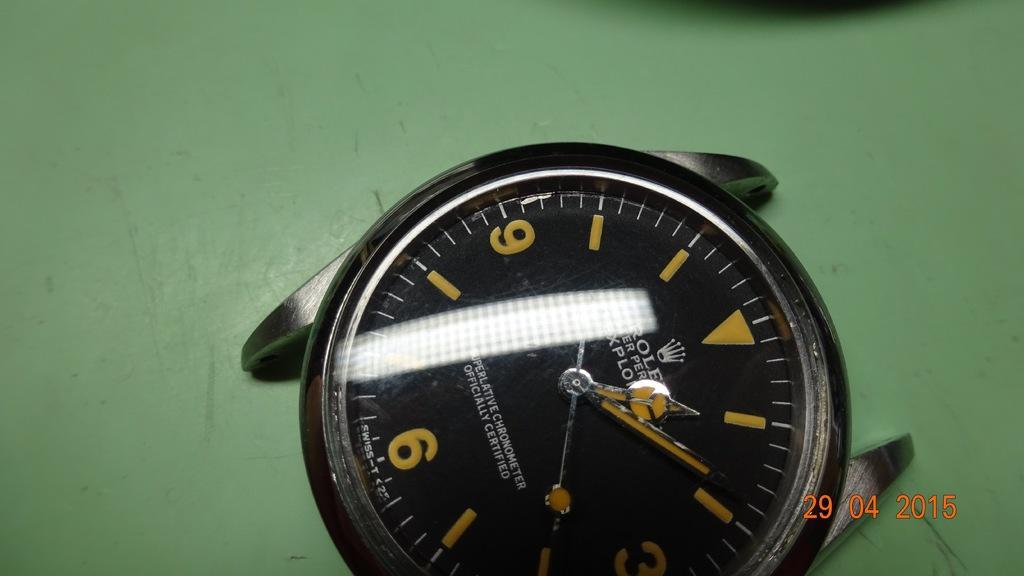Describe this image in one or two sentences. In this image we can see a watch on a green color platform. At the bottom of the image we can see some text. 